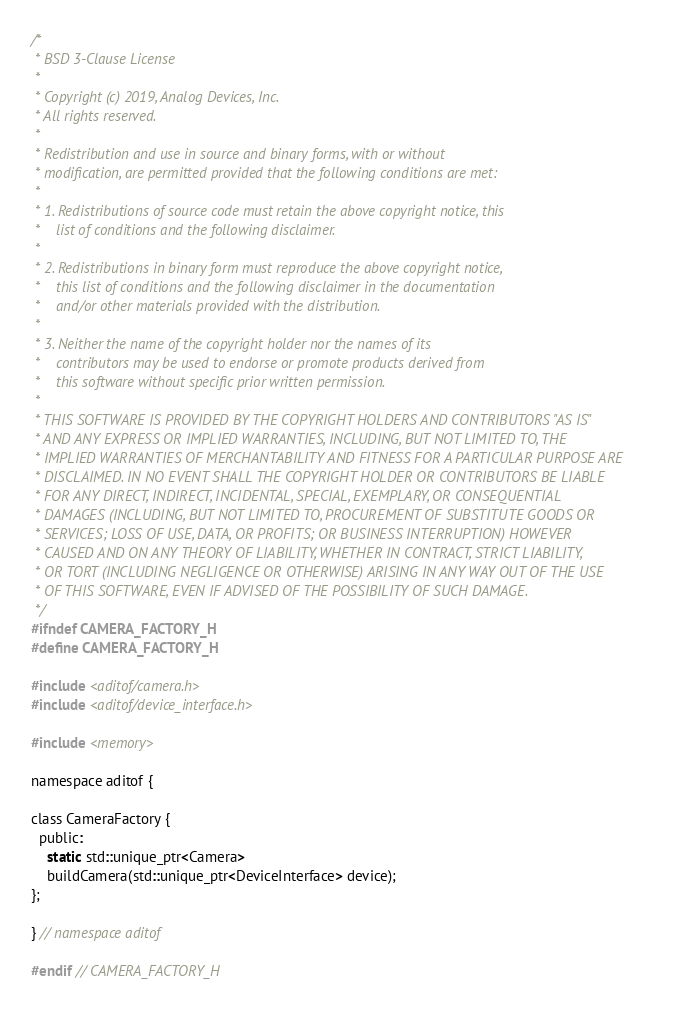Convert code to text. <code><loc_0><loc_0><loc_500><loc_500><_C_>/*
 * BSD 3-Clause License
 *
 * Copyright (c) 2019, Analog Devices, Inc.
 * All rights reserved.
 *
 * Redistribution and use in source and binary forms, with or without
 * modification, are permitted provided that the following conditions are met:
 *
 * 1. Redistributions of source code must retain the above copyright notice, this
 *    list of conditions and the following disclaimer.
 *
 * 2. Redistributions in binary form must reproduce the above copyright notice,
 *    this list of conditions and the following disclaimer in the documentation
 *    and/or other materials provided with the distribution.
 *
 * 3. Neither the name of the copyright holder nor the names of its
 *    contributors may be used to endorse or promote products derived from
 *    this software without specific prior written permission.
 *
 * THIS SOFTWARE IS PROVIDED BY THE COPYRIGHT HOLDERS AND CONTRIBUTORS "AS IS"
 * AND ANY EXPRESS OR IMPLIED WARRANTIES, INCLUDING, BUT NOT LIMITED TO, THE
 * IMPLIED WARRANTIES OF MERCHANTABILITY AND FITNESS FOR A PARTICULAR PURPOSE ARE
 * DISCLAIMED. IN NO EVENT SHALL THE COPYRIGHT HOLDER OR CONTRIBUTORS BE LIABLE
 * FOR ANY DIRECT, INDIRECT, INCIDENTAL, SPECIAL, EXEMPLARY, OR CONSEQUENTIAL
 * DAMAGES (INCLUDING, BUT NOT LIMITED TO, PROCUREMENT OF SUBSTITUTE GOODS OR
 * SERVICES; LOSS OF USE, DATA, OR PROFITS; OR BUSINESS INTERRUPTION) HOWEVER
 * CAUSED AND ON ANY THEORY OF LIABILITY, WHETHER IN CONTRACT, STRICT LIABILITY,
 * OR TORT (INCLUDING NEGLIGENCE OR OTHERWISE) ARISING IN ANY WAY OUT OF THE USE
 * OF THIS SOFTWARE, EVEN IF ADVISED OF THE POSSIBILITY OF SUCH DAMAGE.
 */
#ifndef CAMERA_FACTORY_H
#define CAMERA_FACTORY_H

#include <aditof/camera.h>
#include <aditof/device_interface.h>

#include <memory>

namespace aditof {

class CameraFactory {
  public:
    static std::unique_ptr<Camera>
    buildCamera(std::unique_ptr<DeviceInterface> device);
};

} // namespace aditof

#endif // CAMERA_FACTORY_H
</code> 